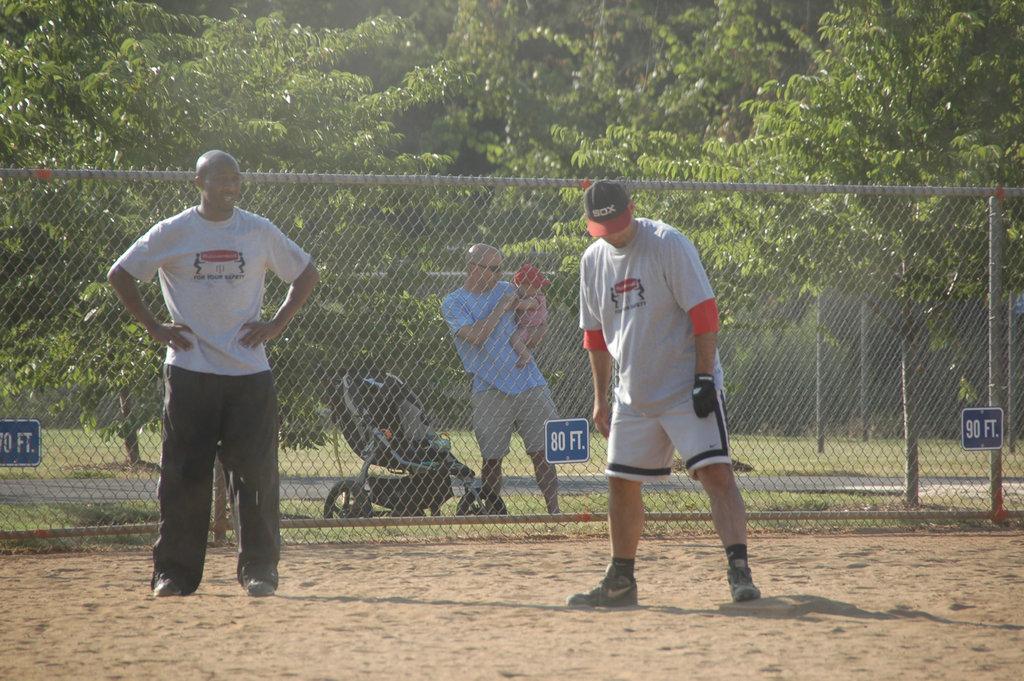How many feet does the sign say in front of the man holding the baby?
Provide a succinct answer. 80. What does the blue sign say on the very right on the fence?
Provide a short and direct response. 90 ft. 